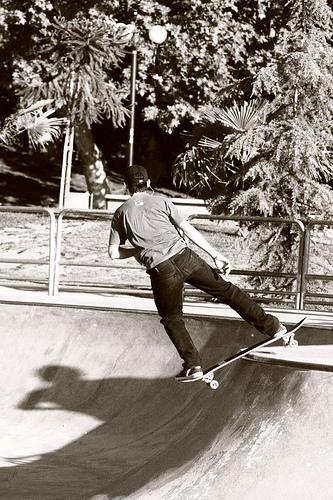How many fingers does the man have?
Write a very short answer. 10. Where is the boy's shadow?
Keep it brief. Left. Is the skateboarder wearing a helmet?
Keep it brief. No. 